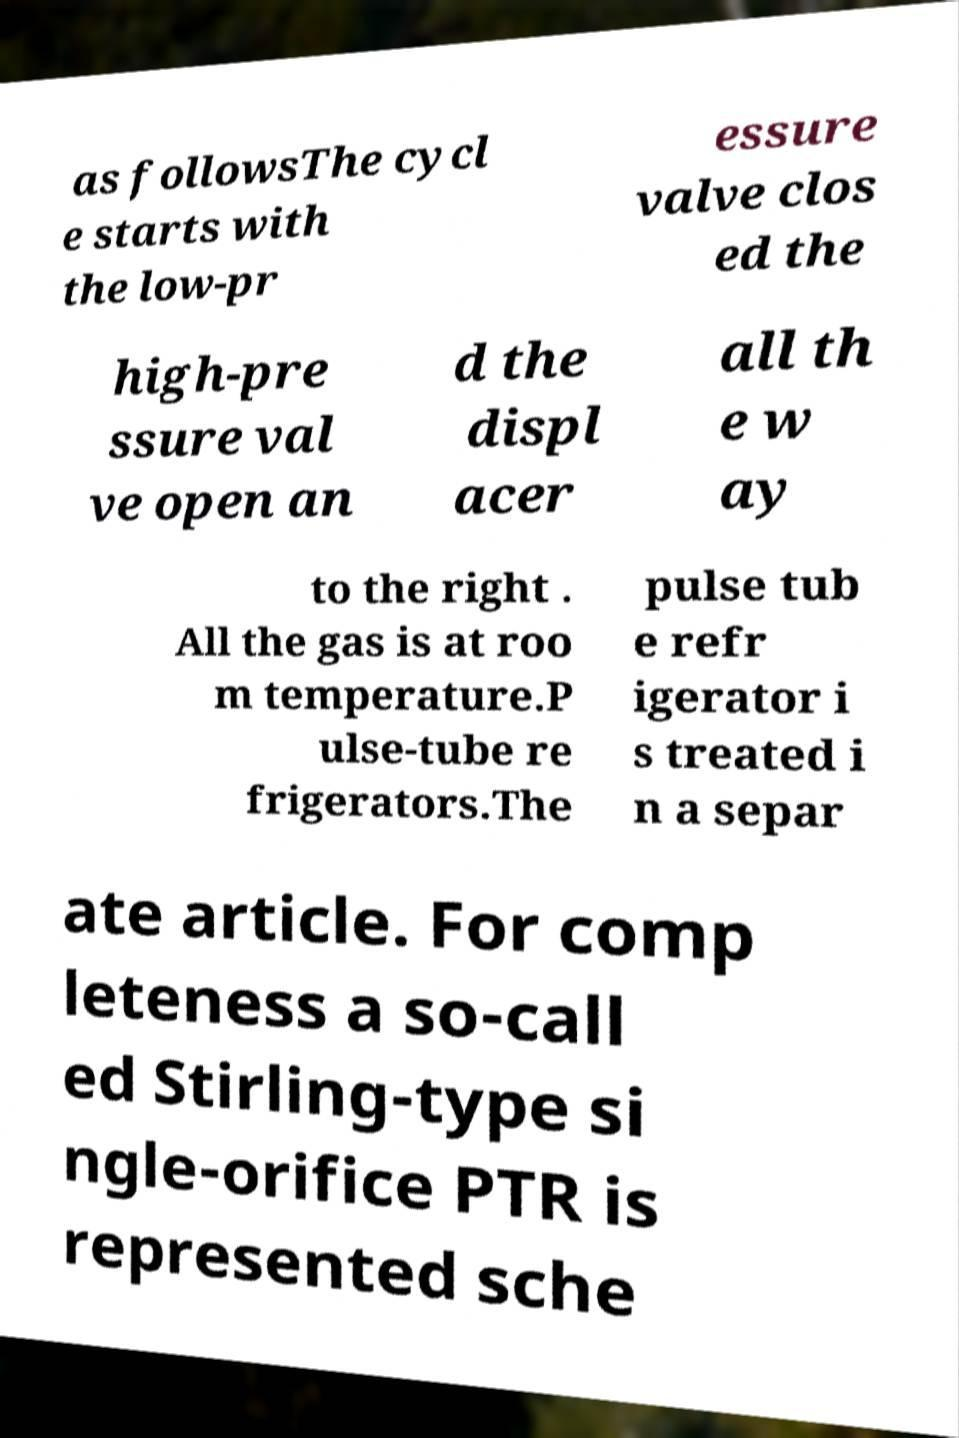Can you read and provide the text displayed in the image?This photo seems to have some interesting text. Can you extract and type it out for me? as followsThe cycl e starts with the low-pr essure valve clos ed the high-pre ssure val ve open an d the displ acer all th e w ay to the right . All the gas is at roo m temperature.P ulse-tube re frigerators.The pulse tub e refr igerator i s treated i n a separ ate article. For comp leteness a so-call ed Stirling-type si ngle-orifice PTR is represented sche 